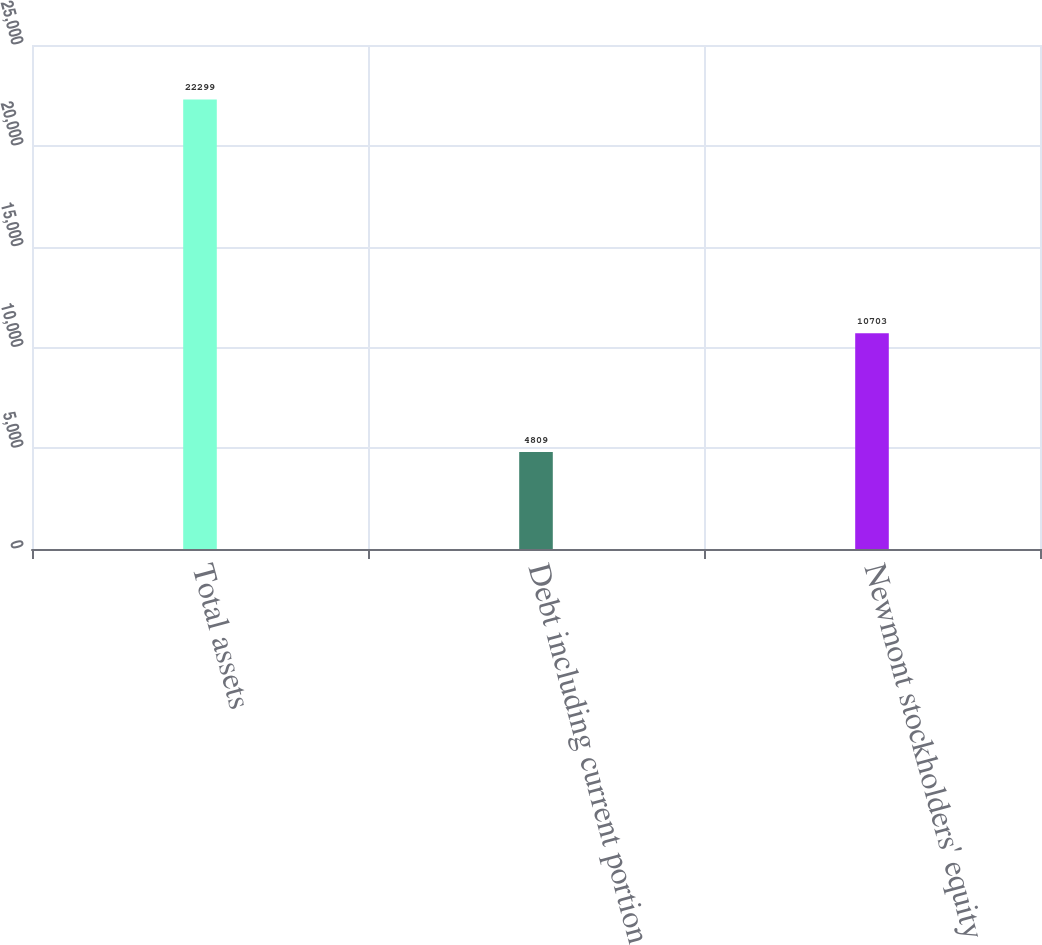Convert chart to OTSL. <chart><loc_0><loc_0><loc_500><loc_500><bar_chart><fcel>Total assets<fcel>Debt including current portion<fcel>Newmont stockholders' equity<nl><fcel>22299<fcel>4809<fcel>10703<nl></chart> 